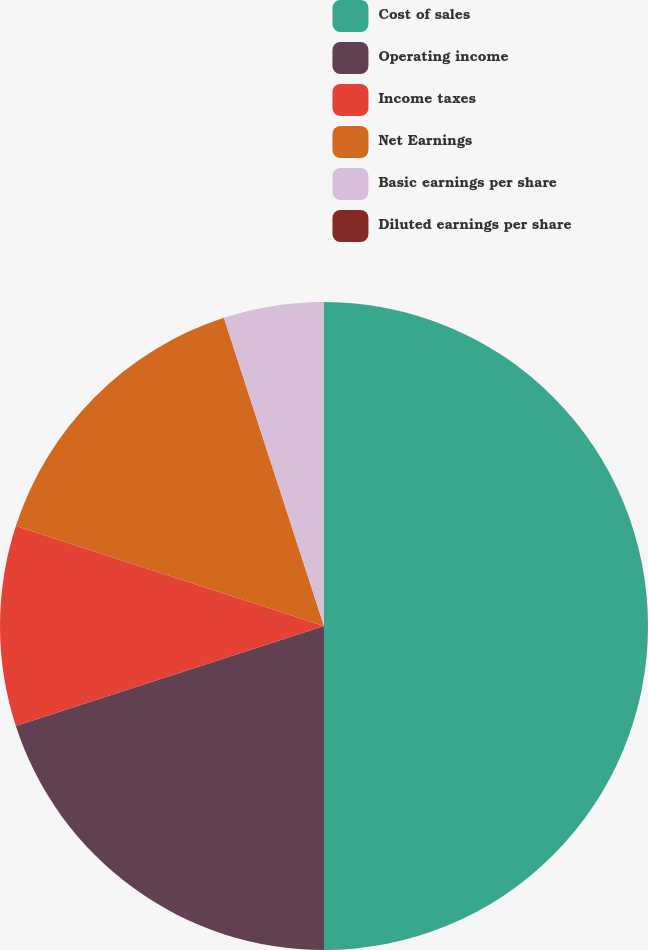Convert chart to OTSL. <chart><loc_0><loc_0><loc_500><loc_500><pie_chart><fcel>Cost of sales<fcel>Operating income<fcel>Income taxes<fcel>Net Earnings<fcel>Basic earnings per share<fcel>Diluted earnings per share<nl><fcel>50.0%<fcel>20.0%<fcel>10.0%<fcel>15.0%<fcel>5.0%<fcel>0.0%<nl></chart> 